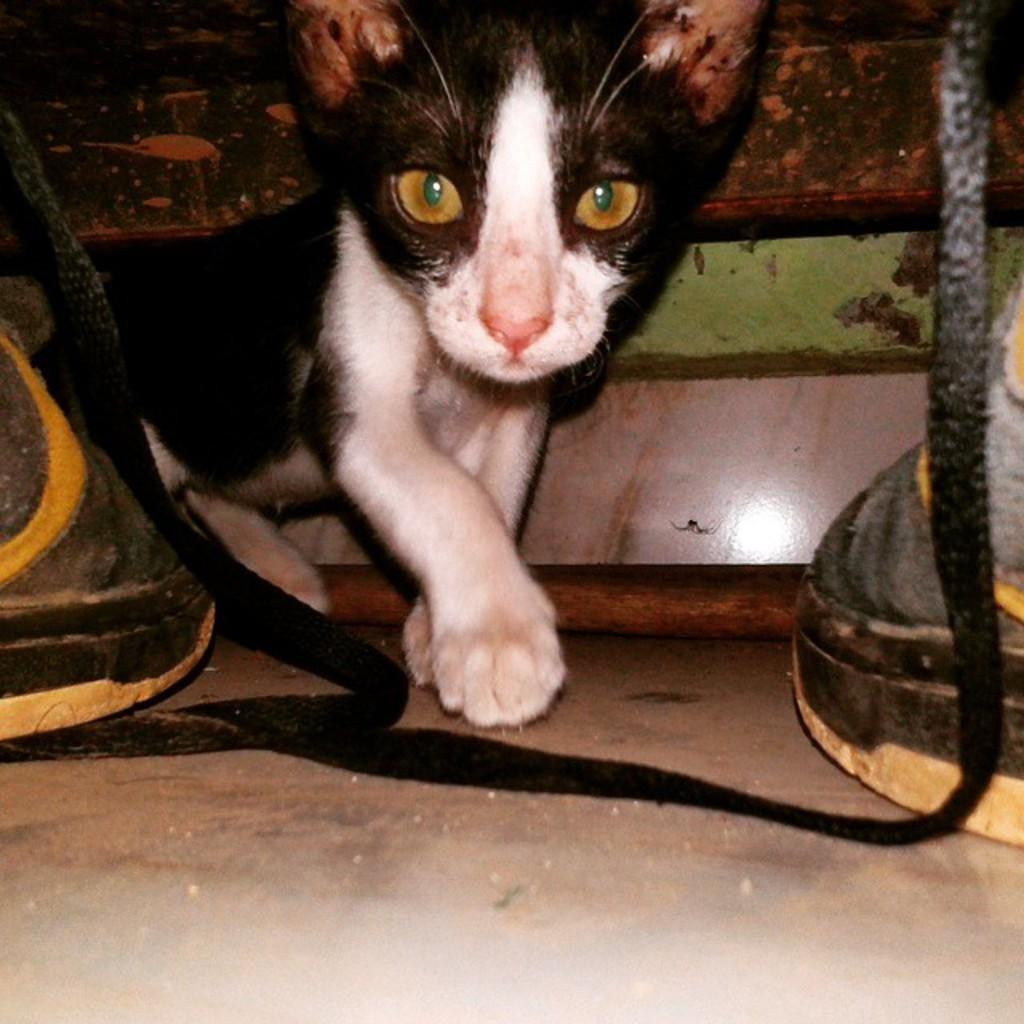What type of animal is in the image? There is a cat in the image. What can be seen beside the cat? There are objects beside the cat in the image. What type of cart is visible in the image? There is no cart present in the image; it only features a cat and objects beside it. 